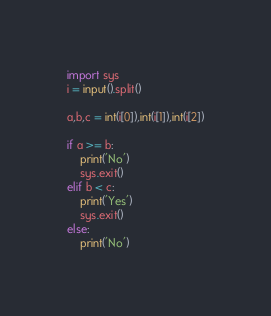Convert code to text. <code><loc_0><loc_0><loc_500><loc_500><_Python_>import sys
i = input().split()

a,b,c = int(i[0]),int(i[1]),int(i[2])

if a >= b:
    print('No')
    sys.exit()
elif b < c:
    print('Yes')
    sys.exit()
else:
    print('No')
</code> 